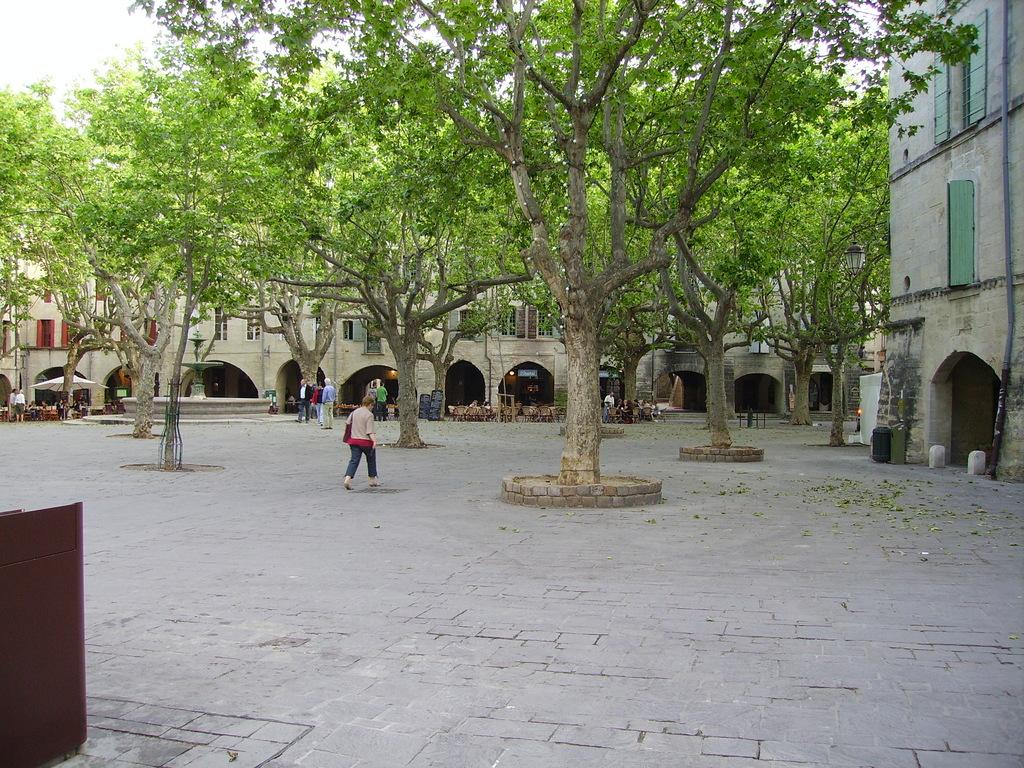What can be seen on the left side of the image? There is an object on the left side of the image. What is the color of the object? The object is brown in color. What can be seen in the background of the image? There are trees and buildings in the background of the image. Are there any people in the image? Yes, there are persons in the image. What type of gate is present in the image? There is no gate present in the image. What does the arm of the person in the image look like? There is no specific detail about the person's arm provided in the image. 